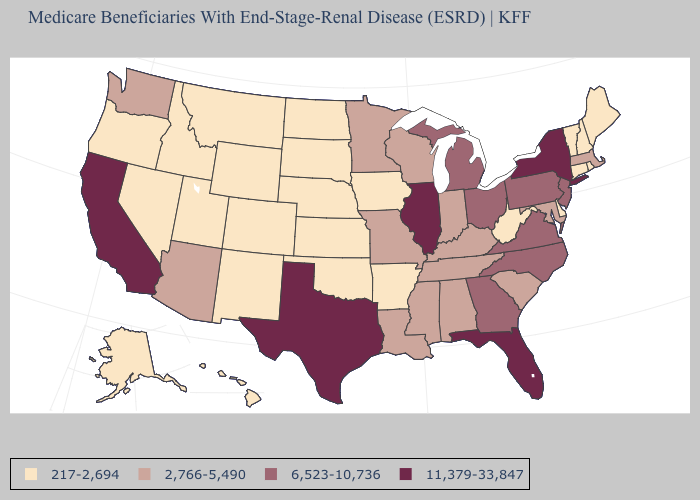Does the map have missing data?
Write a very short answer. No. Name the states that have a value in the range 2,766-5,490?
Answer briefly. Alabama, Arizona, Indiana, Kentucky, Louisiana, Maryland, Massachusetts, Minnesota, Mississippi, Missouri, South Carolina, Tennessee, Washington, Wisconsin. How many symbols are there in the legend?
Quick response, please. 4. What is the value of Pennsylvania?
Answer briefly. 6,523-10,736. What is the highest value in states that border Washington?
Answer briefly. 217-2,694. What is the value of Nevada?
Short answer required. 217-2,694. Name the states that have a value in the range 217-2,694?
Short answer required. Alaska, Arkansas, Colorado, Connecticut, Delaware, Hawaii, Idaho, Iowa, Kansas, Maine, Montana, Nebraska, Nevada, New Hampshire, New Mexico, North Dakota, Oklahoma, Oregon, Rhode Island, South Dakota, Utah, Vermont, West Virginia, Wyoming. What is the value of Alaska?
Answer briefly. 217-2,694. Among the states that border North Dakota , does Montana have the highest value?
Quick response, please. No. What is the highest value in the MidWest ?
Be succinct. 11,379-33,847. Which states hav the highest value in the West?
Write a very short answer. California. What is the value of New Jersey?
Give a very brief answer. 6,523-10,736. Name the states that have a value in the range 2,766-5,490?
Give a very brief answer. Alabama, Arizona, Indiana, Kentucky, Louisiana, Maryland, Massachusetts, Minnesota, Mississippi, Missouri, South Carolina, Tennessee, Washington, Wisconsin. Name the states that have a value in the range 6,523-10,736?
Answer briefly. Georgia, Michigan, New Jersey, North Carolina, Ohio, Pennsylvania, Virginia. What is the value of New Mexico?
Short answer required. 217-2,694. 